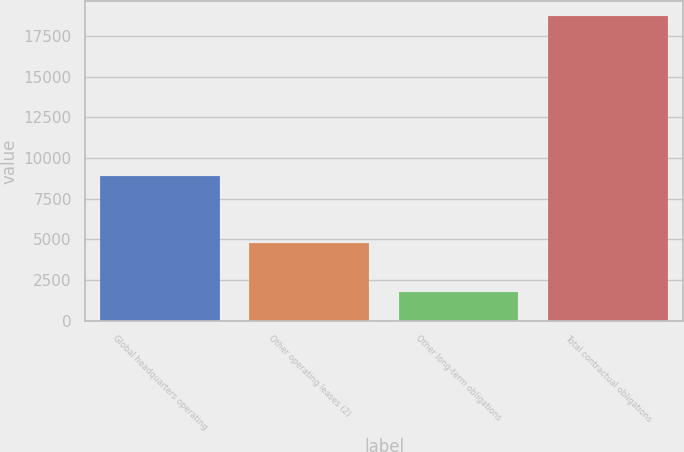Convert chart to OTSL. <chart><loc_0><loc_0><loc_500><loc_500><bar_chart><fcel>Global headquarters operating<fcel>Other operating leases (2)<fcel>Other long-term obligations<fcel>Total contractual obligations<nl><fcel>8928<fcel>4752<fcel>1763<fcel>18712<nl></chart> 